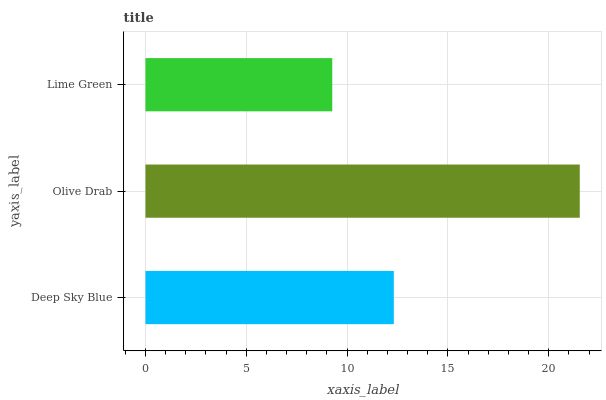Is Lime Green the minimum?
Answer yes or no. Yes. Is Olive Drab the maximum?
Answer yes or no. Yes. Is Olive Drab the minimum?
Answer yes or no. No. Is Lime Green the maximum?
Answer yes or no. No. Is Olive Drab greater than Lime Green?
Answer yes or no. Yes. Is Lime Green less than Olive Drab?
Answer yes or no. Yes. Is Lime Green greater than Olive Drab?
Answer yes or no. No. Is Olive Drab less than Lime Green?
Answer yes or no. No. Is Deep Sky Blue the high median?
Answer yes or no. Yes. Is Deep Sky Blue the low median?
Answer yes or no. Yes. Is Lime Green the high median?
Answer yes or no. No. Is Olive Drab the low median?
Answer yes or no. No. 